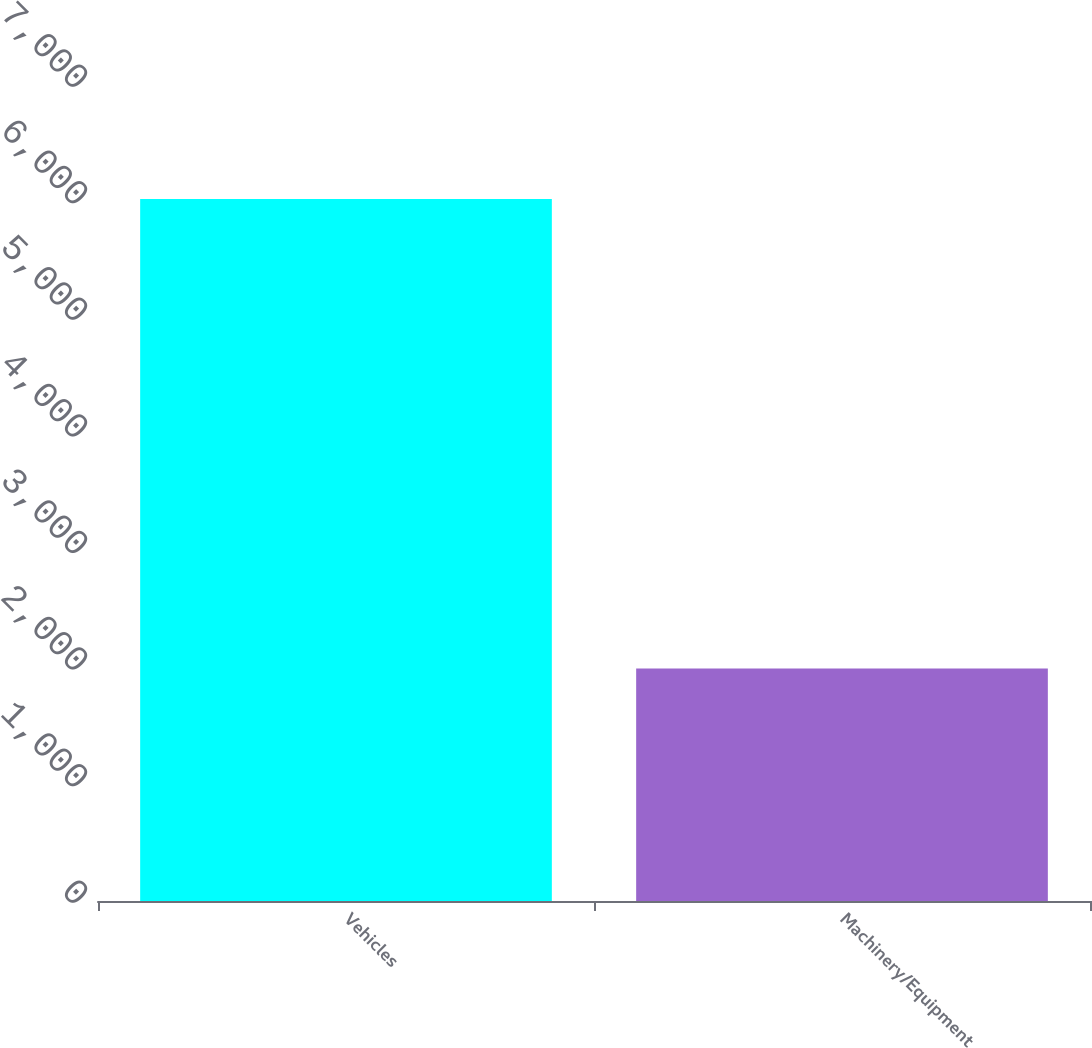Convert chart. <chart><loc_0><loc_0><loc_500><loc_500><bar_chart><fcel>Vehicles<fcel>Machinery/Equipment<nl><fcel>6021<fcel>1994<nl></chart> 